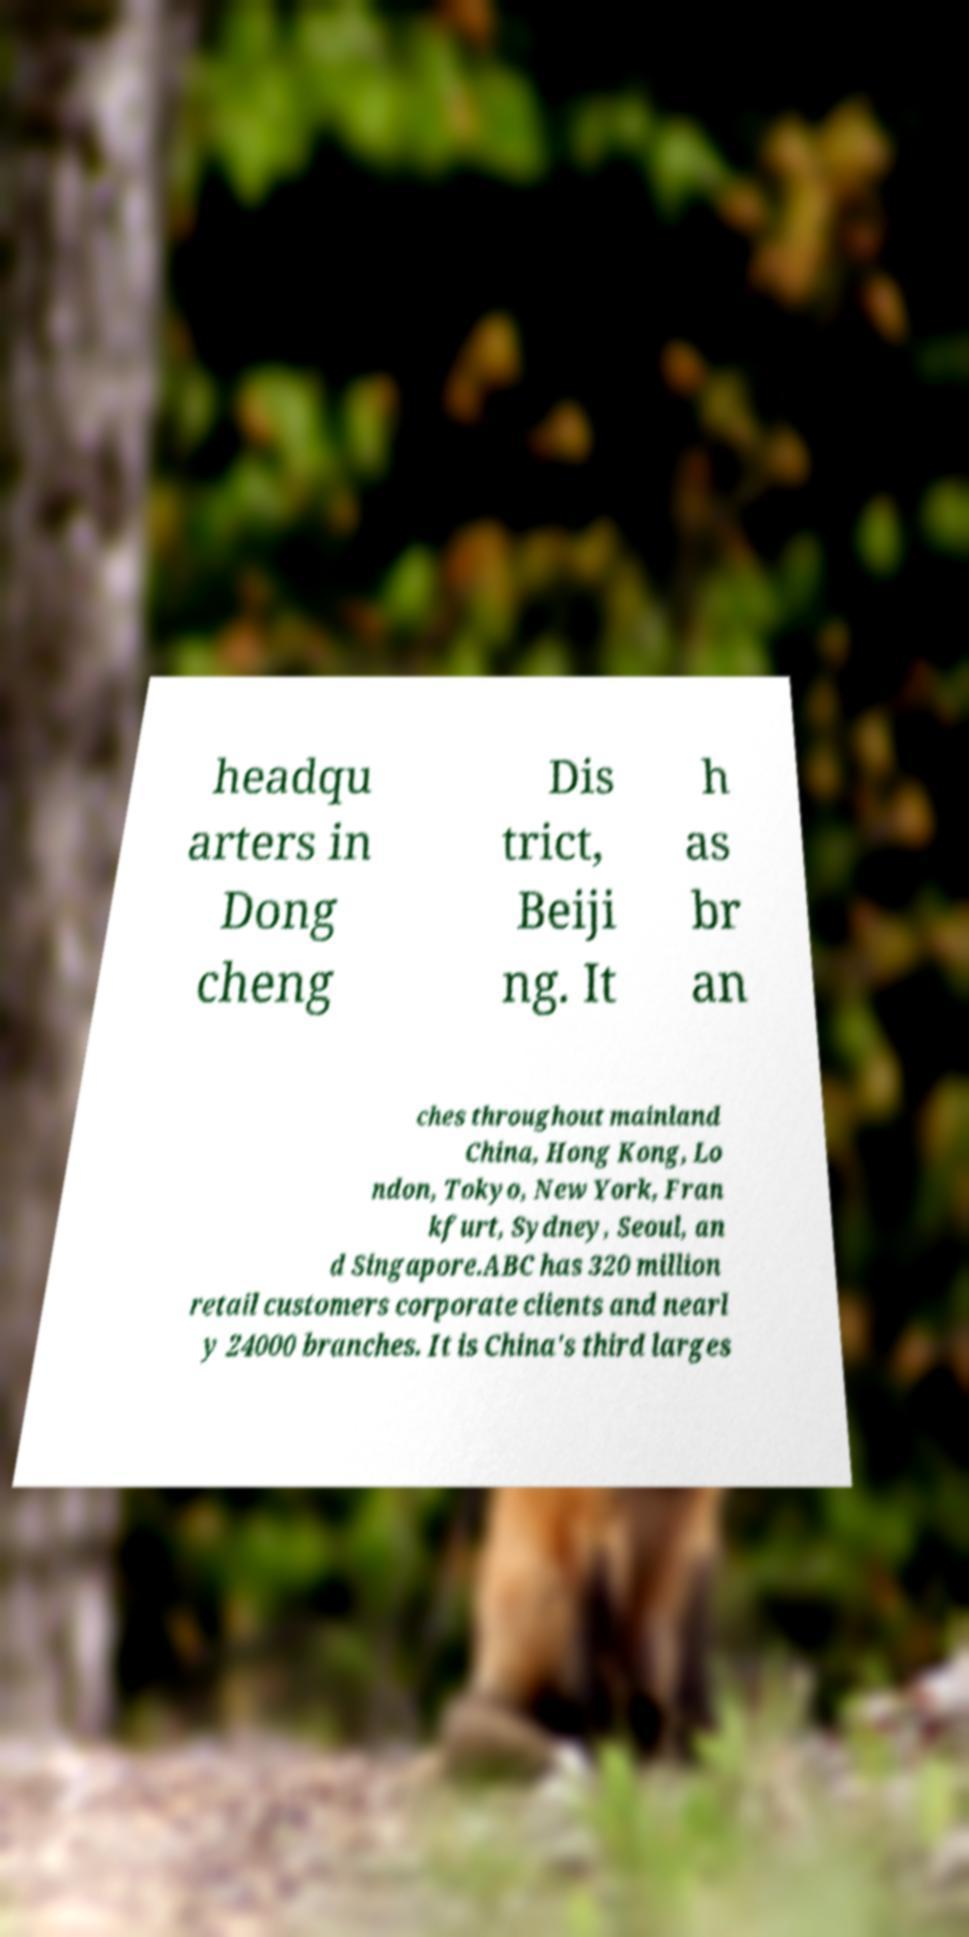I need the written content from this picture converted into text. Can you do that? headqu arters in Dong cheng Dis trict, Beiji ng. It h as br an ches throughout mainland China, Hong Kong, Lo ndon, Tokyo, New York, Fran kfurt, Sydney, Seoul, an d Singapore.ABC has 320 million retail customers corporate clients and nearl y 24000 branches. It is China's third larges 